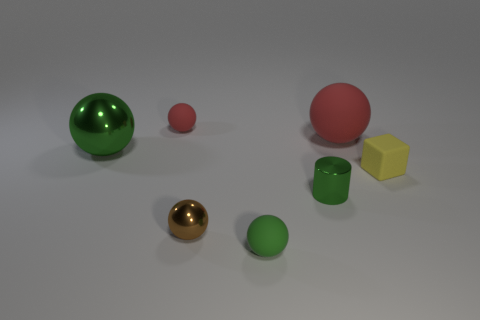Is the color of the tiny metallic sphere the same as the tiny rubber cube?
Your answer should be very brief. No. The big thing behind the thing that is to the left of the tiny rubber ball left of the small green ball is what color?
Your answer should be compact. Red. How many small balls are in front of the large ball behind the green ball that is behind the small yellow cube?
Your answer should be compact. 2. Is there anything else of the same color as the matte block?
Keep it short and to the point. No. Do the green shiny object that is in front of the yellow rubber thing and the brown metal thing have the same size?
Make the answer very short. Yes. How many tiny balls are behind the small shiny thing in front of the green cylinder?
Your response must be concise. 1. Is there a metal sphere behind the big object to the left of the small rubber object behind the matte block?
Provide a succinct answer. No. What is the material of the small green object that is the same shape as the big metal object?
Your answer should be compact. Rubber. Is there any other thing that is the same material as the big red thing?
Provide a short and direct response. Yes. Does the small red thing have the same material as the green object behind the tiny cube?
Offer a very short reply. No. 